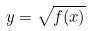Convert formula to latex. <formula><loc_0><loc_0><loc_500><loc_500>y = \sqrt { f ( x ) }</formula> 